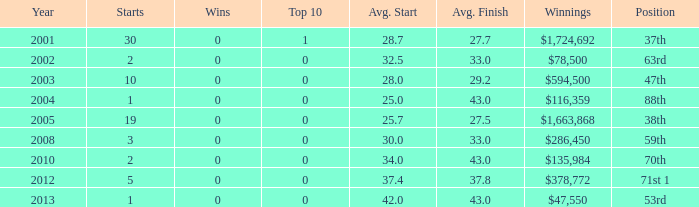Write the full table. {'header': ['Year', 'Starts', 'Wins', 'Top 10', 'Avg. Start', 'Avg. Finish', 'Winnings', 'Position'], 'rows': [['2001', '30', '0', '1', '28.7', '27.7', '$1,724,692', '37th'], ['2002', '2', '0', '0', '32.5', '33.0', '$78,500', '63rd'], ['2003', '10', '0', '0', '28.0', '29.2', '$594,500', '47th'], ['2004', '1', '0', '0', '25.0', '43.0', '$116,359', '88th'], ['2005', '19', '0', '0', '25.7', '27.5', '$1,663,868', '38th'], ['2008', '3', '0', '0', '30.0', '33.0', '$286,450', '59th'], ['2010', '2', '0', '0', '34.0', '43.0', '$135,984', '70th'], ['2012', '5', '0', '0', '37.4', '37.8', '$378,772', '71st 1'], ['2013', '1', '0', '0', '42.0', '43.0', '$47,550', '53rd']]} How many wins for average start less than 25? 0.0. 